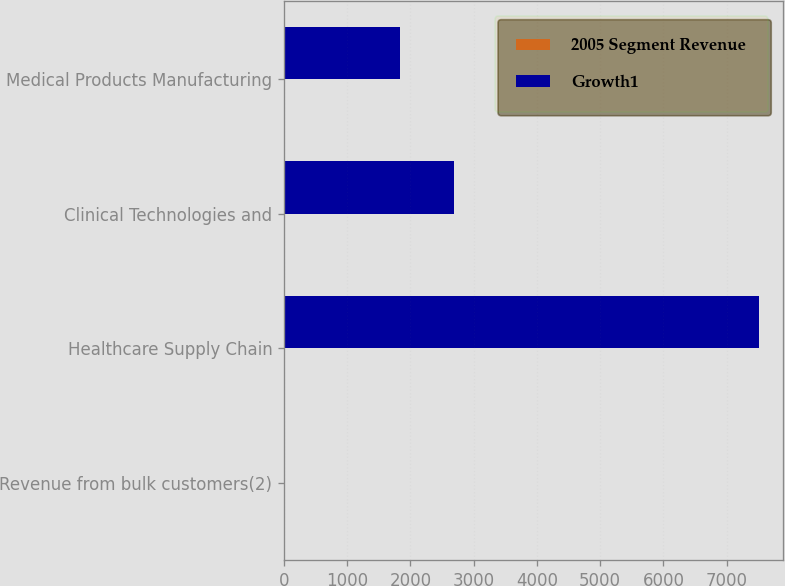<chart> <loc_0><loc_0><loc_500><loc_500><stacked_bar_chart><ecel><fcel>Revenue from bulk customers(2)<fcel>Healthcare Supply Chain<fcel>Clinical Technologies and<fcel>Medical Products Manufacturing<nl><fcel>2005 Segment Revenue<fcel>13<fcel>4<fcel>11<fcel>12<nl><fcel>Growth1<fcel>13<fcel>7513.9<fcel>2687<fcel>1835.9<nl></chart> 